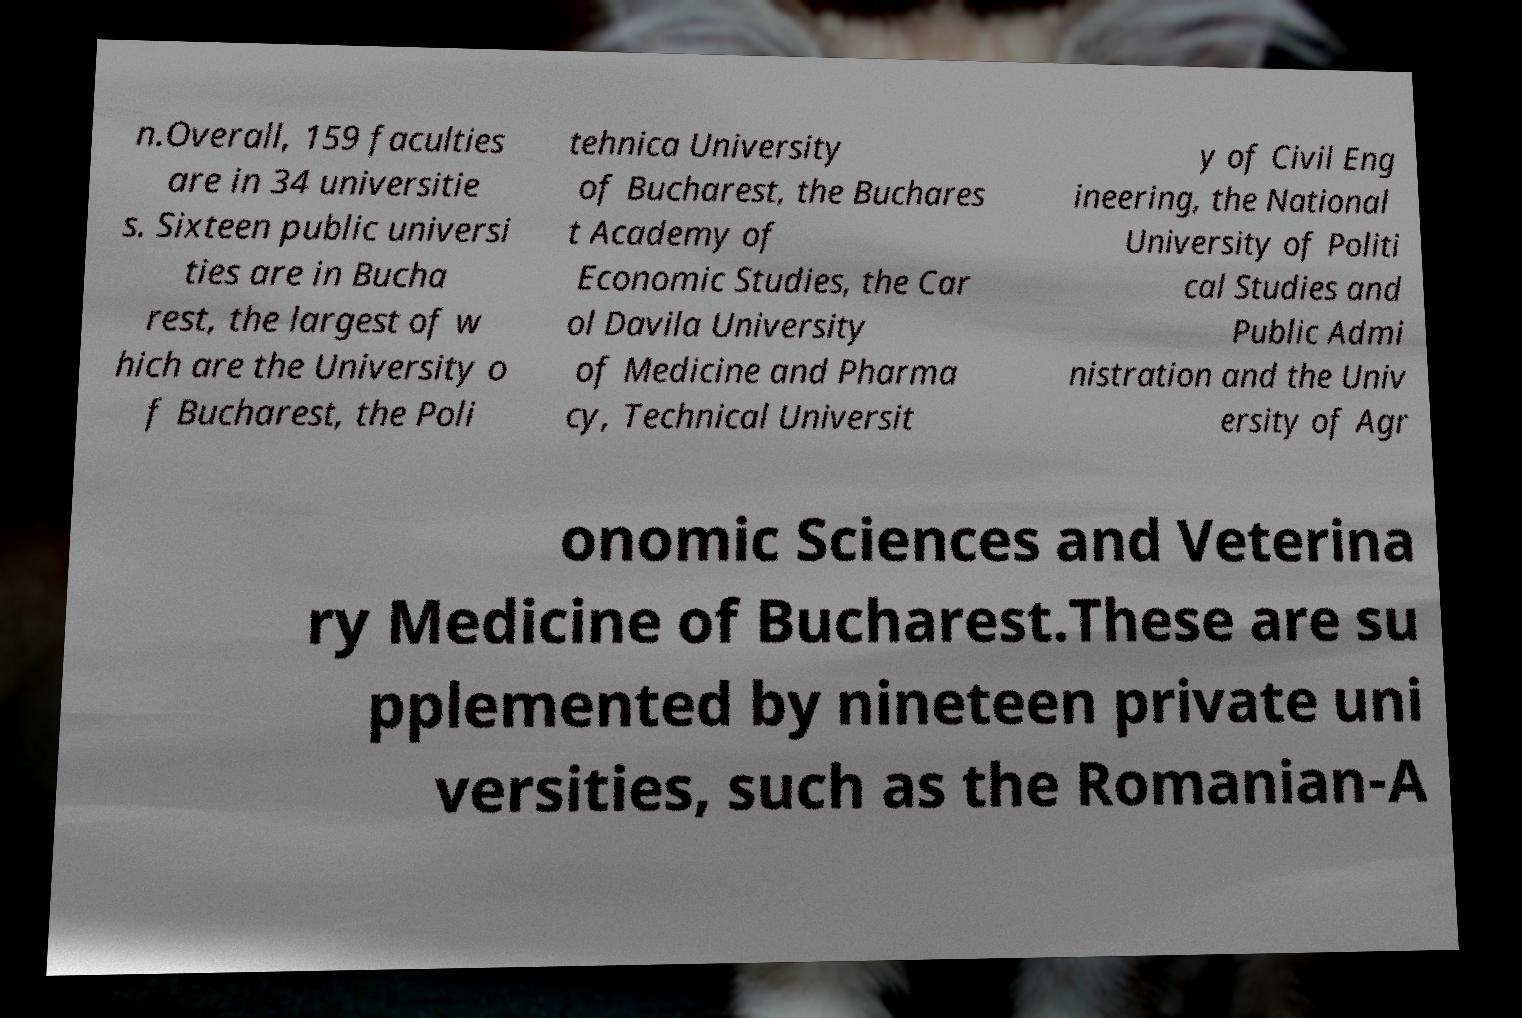I need the written content from this picture converted into text. Can you do that? n.Overall, 159 faculties are in 34 universitie s. Sixteen public universi ties are in Bucha rest, the largest of w hich are the University o f Bucharest, the Poli tehnica University of Bucharest, the Buchares t Academy of Economic Studies, the Car ol Davila University of Medicine and Pharma cy, Technical Universit y of Civil Eng ineering, the National University of Politi cal Studies and Public Admi nistration and the Univ ersity of Agr onomic Sciences and Veterina ry Medicine of Bucharest.These are su pplemented by nineteen private uni versities, such as the Romanian-A 